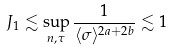<formula> <loc_0><loc_0><loc_500><loc_500>J _ { 1 } \lesssim \sup _ { n , \tau } \frac { 1 } { \langle \sigma \rangle ^ { 2 a + 2 b } } \lesssim 1</formula> 